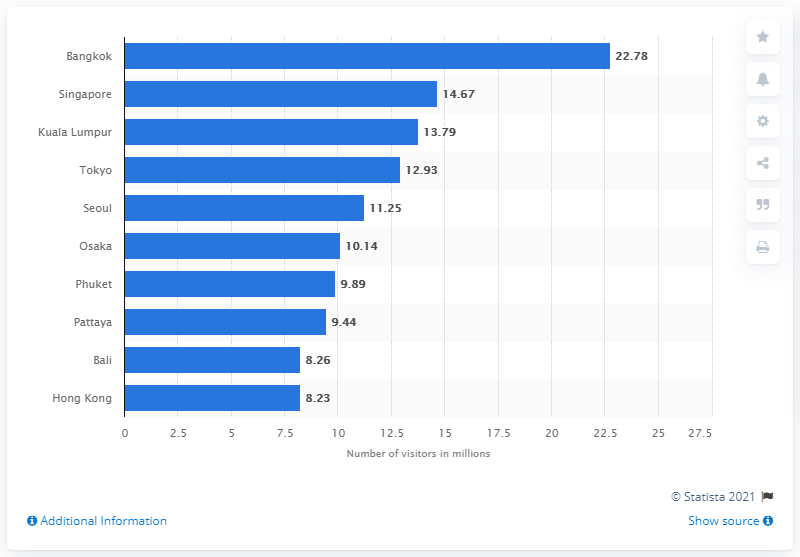Give some essential details in this illustration. According to data from the Asia Pacific region in 2018, Bangkok was the most popular city visited by tourists. In 2018, Bangkok received a total of 22,780 international overnight visitors. In 2018, Hong Kong received a total of 8,260,000 international overnight visitors. 